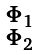<formula> <loc_0><loc_0><loc_500><loc_500>\begin{smallmatrix} \Phi _ { 1 } \\ \Phi _ { 2 } \end{smallmatrix}</formula> 